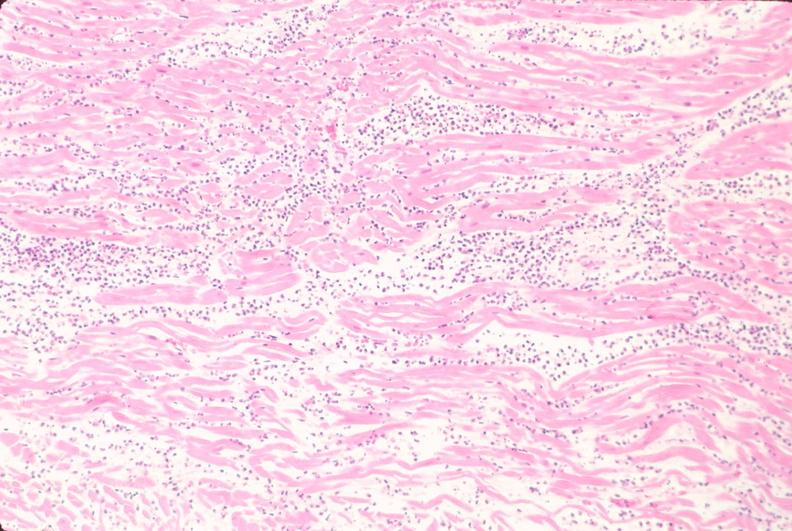does beckwith-wiedemann syndrome show heart, acute myocardial infarction, he?
Answer the question using a single word or phrase. No 